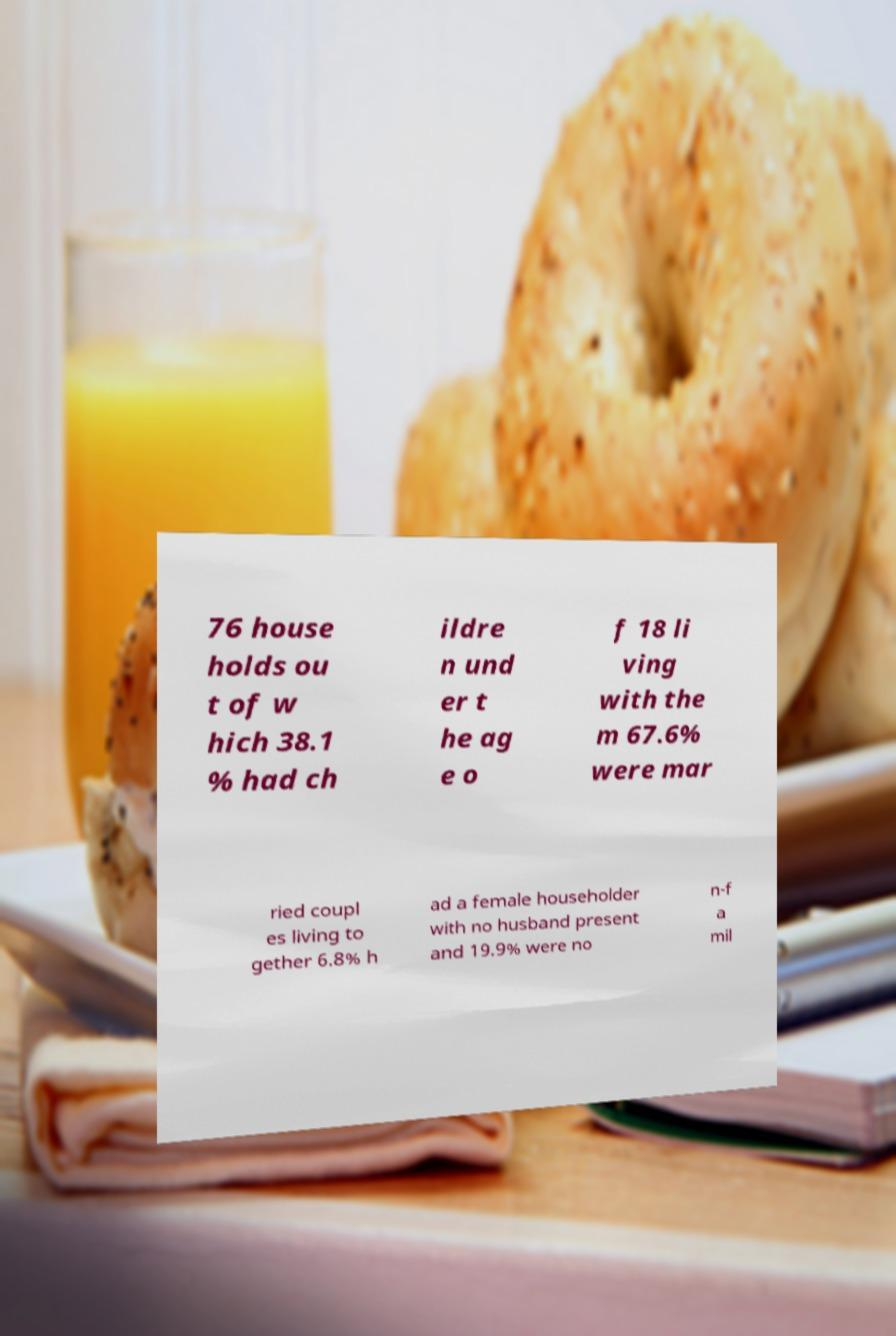Can you read and provide the text displayed in the image?This photo seems to have some interesting text. Can you extract and type it out for me? 76 house holds ou t of w hich 38.1 % had ch ildre n und er t he ag e o f 18 li ving with the m 67.6% were mar ried coupl es living to gether 6.8% h ad a female householder with no husband present and 19.9% were no n-f a mil 